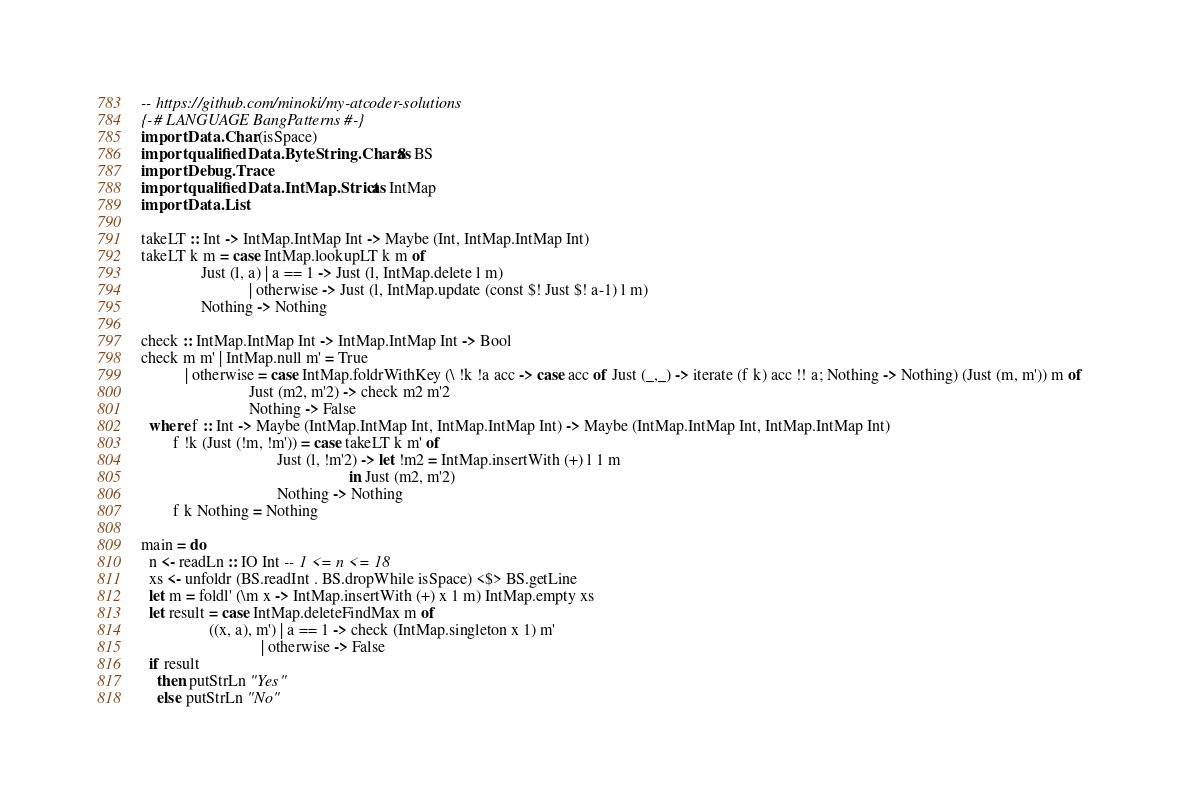<code> <loc_0><loc_0><loc_500><loc_500><_Haskell_>-- https://github.com/minoki/my-atcoder-solutions
{-# LANGUAGE BangPatterns #-}
import Data.Char (isSpace)
import qualified Data.ByteString.Char8 as BS
import Debug.Trace
import qualified Data.IntMap.Strict as IntMap
import Data.List

takeLT :: Int -> IntMap.IntMap Int -> Maybe (Int, IntMap.IntMap Int)
takeLT k m = case IntMap.lookupLT k m of
               Just (l, a) | a == 1 -> Just (l, IntMap.delete l m)
                           | otherwise -> Just (l, IntMap.update (const $! Just $! a-1) l m)
               Nothing -> Nothing

check :: IntMap.IntMap Int -> IntMap.IntMap Int -> Bool
check m m' | IntMap.null m' = True
           | otherwise = case IntMap.foldrWithKey (\ !k !a acc -> case acc of Just (_,_) -> iterate (f k) acc !! a; Nothing -> Nothing) (Just (m, m')) m of
                           Just (m2, m'2) -> check m2 m'2
                           Nothing -> False
  where f :: Int -> Maybe (IntMap.IntMap Int, IntMap.IntMap Int) -> Maybe (IntMap.IntMap Int, IntMap.IntMap Int)
        f !k (Just (!m, !m')) = case takeLT k m' of
                                  Just (l, !m'2) -> let !m2 = IntMap.insertWith (+) l 1 m
                                                    in Just (m2, m'2)
                                  Nothing -> Nothing
        f k Nothing = Nothing

main = do
  n <- readLn :: IO Int -- 1 <= n <= 18
  xs <- unfoldr (BS.readInt . BS.dropWhile isSpace) <$> BS.getLine
  let m = foldl' (\m x -> IntMap.insertWith (+) x 1 m) IntMap.empty xs
  let result = case IntMap.deleteFindMax m of
                 ((x, a), m') | a == 1 -> check (IntMap.singleton x 1) m'
                              | otherwise -> False
  if result
    then putStrLn "Yes"
    else putStrLn "No"
</code> 